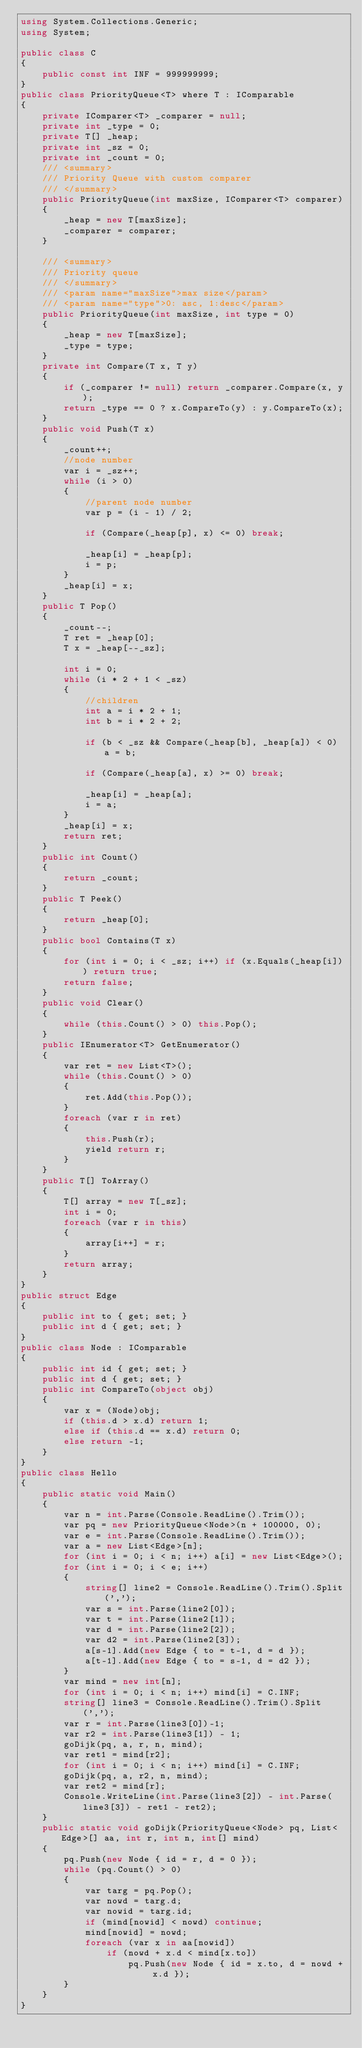Convert code to text. <code><loc_0><loc_0><loc_500><loc_500><_C#_>using System.Collections.Generic;
using System;

public class C
{
    public const int INF = 999999999;
}
public class PriorityQueue<T> where T : IComparable
{
    private IComparer<T> _comparer = null;
    private int _type = 0;
    private T[] _heap;
    private int _sz = 0;
    private int _count = 0;
    /// <summary>
    /// Priority Queue with custom comparer
    /// </summary>
    public PriorityQueue(int maxSize, IComparer<T> comparer)
    {
        _heap = new T[maxSize];
        _comparer = comparer;
    }

    /// <summary>
    /// Priority queue
    /// </summary>
    /// <param name="maxSize">max size</param>
    /// <param name="type">0: asc, 1:desc</param>
    public PriorityQueue(int maxSize, int type = 0)
    {
        _heap = new T[maxSize];
        _type = type;
    }
    private int Compare(T x, T y)
    {
        if (_comparer != null) return _comparer.Compare(x, y);
        return _type == 0 ? x.CompareTo(y) : y.CompareTo(x);
    }
    public void Push(T x)
    {
        _count++;
        //node number
        var i = _sz++;
        while (i > 0)
        {
            //parent node number
            var p = (i - 1) / 2;

            if (Compare(_heap[p], x) <= 0) break;

            _heap[i] = _heap[p];
            i = p;
        }
        _heap[i] = x;
    }
    public T Pop()
    {
        _count--;
        T ret = _heap[0];
        T x = _heap[--_sz];

        int i = 0;
        while (i * 2 + 1 < _sz)
        {
            //children
            int a = i * 2 + 1;
            int b = i * 2 + 2;

            if (b < _sz && Compare(_heap[b], _heap[a]) < 0) a = b;

            if (Compare(_heap[a], x) >= 0) break;

            _heap[i] = _heap[a];
            i = a;
        }
        _heap[i] = x;
        return ret;
    }
    public int Count()
    {
        return _count;
    }
    public T Peek()
    {
        return _heap[0];
    }
    public bool Contains(T x)
    {
        for (int i = 0; i < _sz; i++) if (x.Equals(_heap[i])) return true;
        return false;
    }
    public void Clear()
    {
        while (this.Count() > 0) this.Pop();
    }
    public IEnumerator<T> GetEnumerator()
    {
        var ret = new List<T>();
        while (this.Count() > 0)
        {
            ret.Add(this.Pop());
        }
        foreach (var r in ret)
        {
            this.Push(r);
            yield return r;
        }
    }
    public T[] ToArray()
    {
        T[] array = new T[_sz];
        int i = 0;
        foreach (var r in this)
        {
            array[i++] = r;
        }
        return array;
    }
}
public struct Edge
{
    public int to { get; set; }
    public int d { get; set; }
}
public class Node : IComparable
{
    public int id { get; set; }
    public int d { get; set; }
    public int CompareTo(object obj)
    {
        var x = (Node)obj;
        if (this.d > x.d) return 1;
        else if (this.d == x.d) return 0;
        else return -1;
    }
}
public class Hello
{
    public static void Main()
    {
        var n = int.Parse(Console.ReadLine().Trim());
        var pq = new PriorityQueue<Node>(n + 100000, 0);
        var e = int.Parse(Console.ReadLine().Trim());
        var a = new List<Edge>[n];
        for (int i = 0; i < n; i++) a[i] = new List<Edge>();
        for (int i = 0; i < e; i++)
        {
            string[] line2 = Console.ReadLine().Trim().Split(',');
            var s = int.Parse(line2[0]);
            var t = int.Parse(line2[1]);
            var d = int.Parse(line2[2]);
            var d2 = int.Parse(line2[3]);
            a[s-1].Add(new Edge { to = t-1, d = d });
            a[t-1].Add(new Edge { to = s-1, d = d2 });
        }
        var mind = new int[n];
        for (int i = 0; i < n; i++) mind[i] = C.INF;
        string[] line3 = Console.ReadLine().Trim().Split(',');
        var r = int.Parse(line3[0])-1;
        var r2 = int.Parse(line3[1]) - 1;
        goDijk(pq, a, r, n, mind);
        var ret1 = mind[r2];
        for (int i = 0; i < n; i++) mind[i] = C.INF;
        goDijk(pq, a, r2, n, mind);
        var ret2 = mind[r];
        Console.WriteLine(int.Parse(line3[2]) - int.Parse(line3[3]) - ret1 - ret2);
    }
    public static void goDijk(PriorityQueue<Node> pq, List<Edge>[] aa, int r, int n, int[] mind)
    {
        pq.Push(new Node { id = r, d = 0 });
        while (pq.Count() > 0)
        {
            var targ = pq.Pop();
            var nowd = targ.d;
            var nowid = targ.id;
            if (mind[nowid] < nowd) continue;
            mind[nowid] = nowd;
            foreach (var x in aa[nowid])
                if (nowd + x.d < mind[x.to])
                    pq.Push(new Node { id = x.to, d = nowd + x.d });
        }
    }
}</code> 